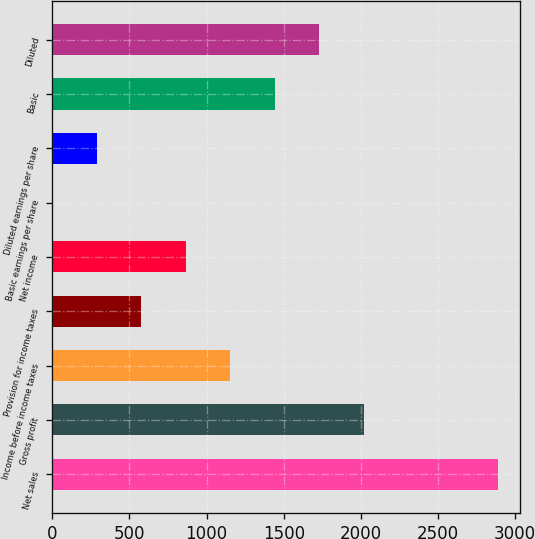Convert chart. <chart><loc_0><loc_0><loc_500><loc_500><bar_chart><fcel>Net sales<fcel>Gross profit<fcel>Income before income taxes<fcel>Provision for income taxes<fcel>Net income<fcel>Basic earnings per share<fcel>Diluted earnings per share<fcel>Basic<fcel>Diluted<nl><fcel>2886<fcel>2020.25<fcel>1154.51<fcel>577.35<fcel>865.93<fcel>0.19<fcel>288.77<fcel>1443.09<fcel>1731.67<nl></chart> 